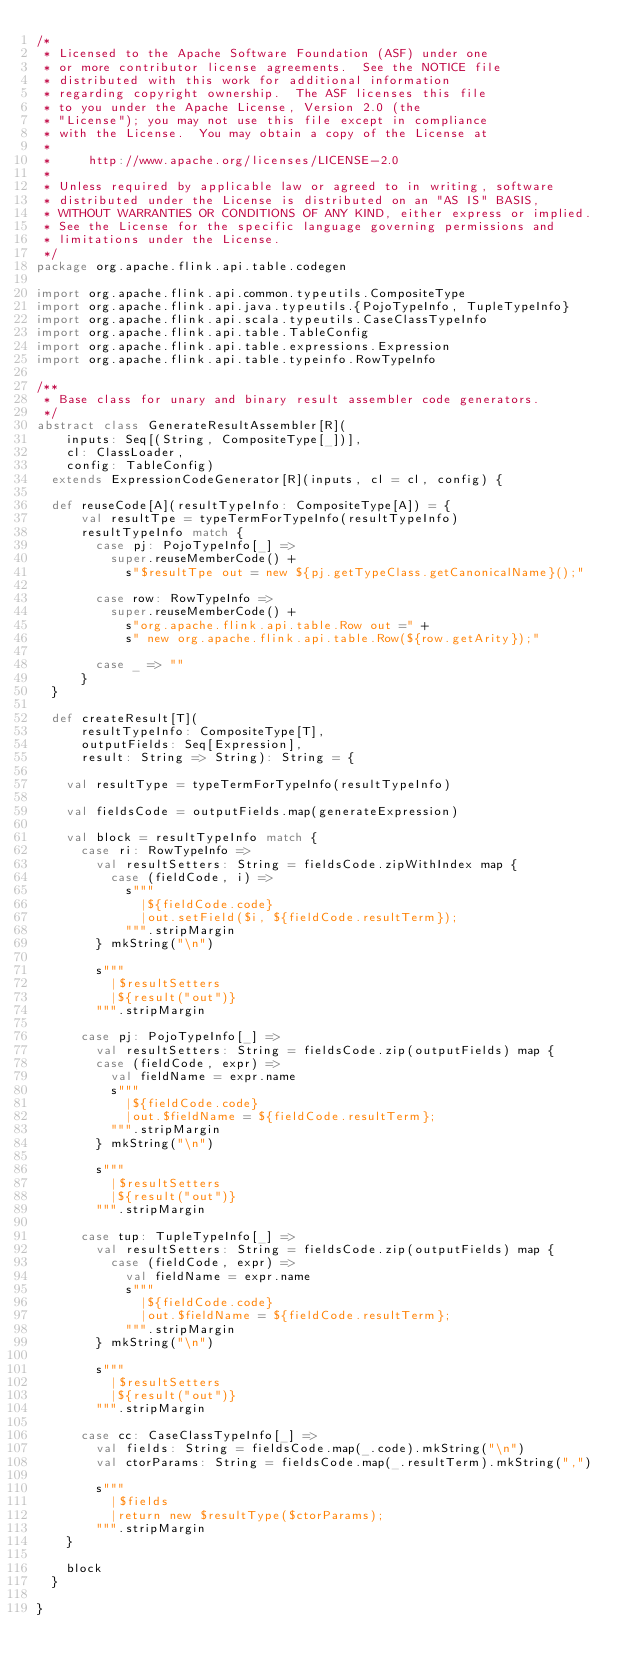<code> <loc_0><loc_0><loc_500><loc_500><_Scala_>/*
 * Licensed to the Apache Software Foundation (ASF) under one
 * or more contributor license agreements.  See the NOTICE file
 * distributed with this work for additional information
 * regarding copyright ownership.  The ASF licenses this file
 * to you under the Apache License, Version 2.0 (the
 * "License"); you may not use this file except in compliance
 * with the License.  You may obtain a copy of the License at
 *
 *     http://www.apache.org/licenses/LICENSE-2.0
 *
 * Unless required by applicable law or agreed to in writing, software
 * distributed under the License is distributed on an "AS IS" BASIS,
 * WITHOUT WARRANTIES OR CONDITIONS OF ANY KIND, either express or implied.
 * See the License for the specific language governing permissions and
 * limitations under the License.
 */
package org.apache.flink.api.table.codegen

import org.apache.flink.api.common.typeutils.CompositeType
import org.apache.flink.api.java.typeutils.{PojoTypeInfo, TupleTypeInfo}
import org.apache.flink.api.scala.typeutils.CaseClassTypeInfo
import org.apache.flink.api.table.TableConfig
import org.apache.flink.api.table.expressions.Expression
import org.apache.flink.api.table.typeinfo.RowTypeInfo

/**
 * Base class for unary and binary result assembler code generators.
 */
abstract class GenerateResultAssembler[R](
    inputs: Seq[(String, CompositeType[_])],
    cl: ClassLoader,
    config: TableConfig)
  extends ExpressionCodeGenerator[R](inputs, cl = cl, config) {

  def reuseCode[A](resultTypeInfo: CompositeType[A]) = {
      val resultTpe = typeTermForTypeInfo(resultTypeInfo)
      resultTypeInfo match {
        case pj: PojoTypeInfo[_] =>
          super.reuseMemberCode() +
            s"$resultTpe out = new ${pj.getTypeClass.getCanonicalName}();"

        case row: RowTypeInfo =>
          super.reuseMemberCode() +
            s"org.apache.flink.api.table.Row out =" +
            s" new org.apache.flink.api.table.Row(${row.getArity});"

        case _ => ""
      }
  }

  def createResult[T](
      resultTypeInfo: CompositeType[T],
      outputFields: Seq[Expression],
      result: String => String): String = {

    val resultType = typeTermForTypeInfo(resultTypeInfo)

    val fieldsCode = outputFields.map(generateExpression)

    val block = resultTypeInfo match {
      case ri: RowTypeInfo =>
        val resultSetters: String = fieldsCode.zipWithIndex map {
          case (fieldCode, i) =>
            s"""
              |${fieldCode.code}
              |out.setField($i, ${fieldCode.resultTerm});
            """.stripMargin
        } mkString("\n")

        s"""
          |$resultSetters
          |${result("out")}
        """.stripMargin

      case pj: PojoTypeInfo[_] =>
        val resultSetters: String = fieldsCode.zip(outputFields) map {
        case (fieldCode, expr) =>
          val fieldName = expr.name
          s"""
            |${fieldCode.code}
            |out.$fieldName = ${fieldCode.resultTerm};
          """.stripMargin
        } mkString("\n")

        s"""
          |$resultSetters
          |${result("out")}
        """.stripMargin

      case tup: TupleTypeInfo[_] =>
        val resultSetters: String = fieldsCode.zip(outputFields) map {
          case (fieldCode, expr) =>
            val fieldName = expr.name
            s"""
              |${fieldCode.code}
              |out.$fieldName = ${fieldCode.resultTerm};
            """.stripMargin
        } mkString("\n")

        s"""
          |$resultSetters
          |${result("out")}
        """.stripMargin

      case cc: CaseClassTypeInfo[_] =>
        val fields: String = fieldsCode.map(_.code).mkString("\n")
        val ctorParams: String = fieldsCode.map(_.resultTerm).mkString(",")

        s"""
          |$fields
          |return new $resultType($ctorParams);
        """.stripMargin
    }

    block
  }

}
</code> 